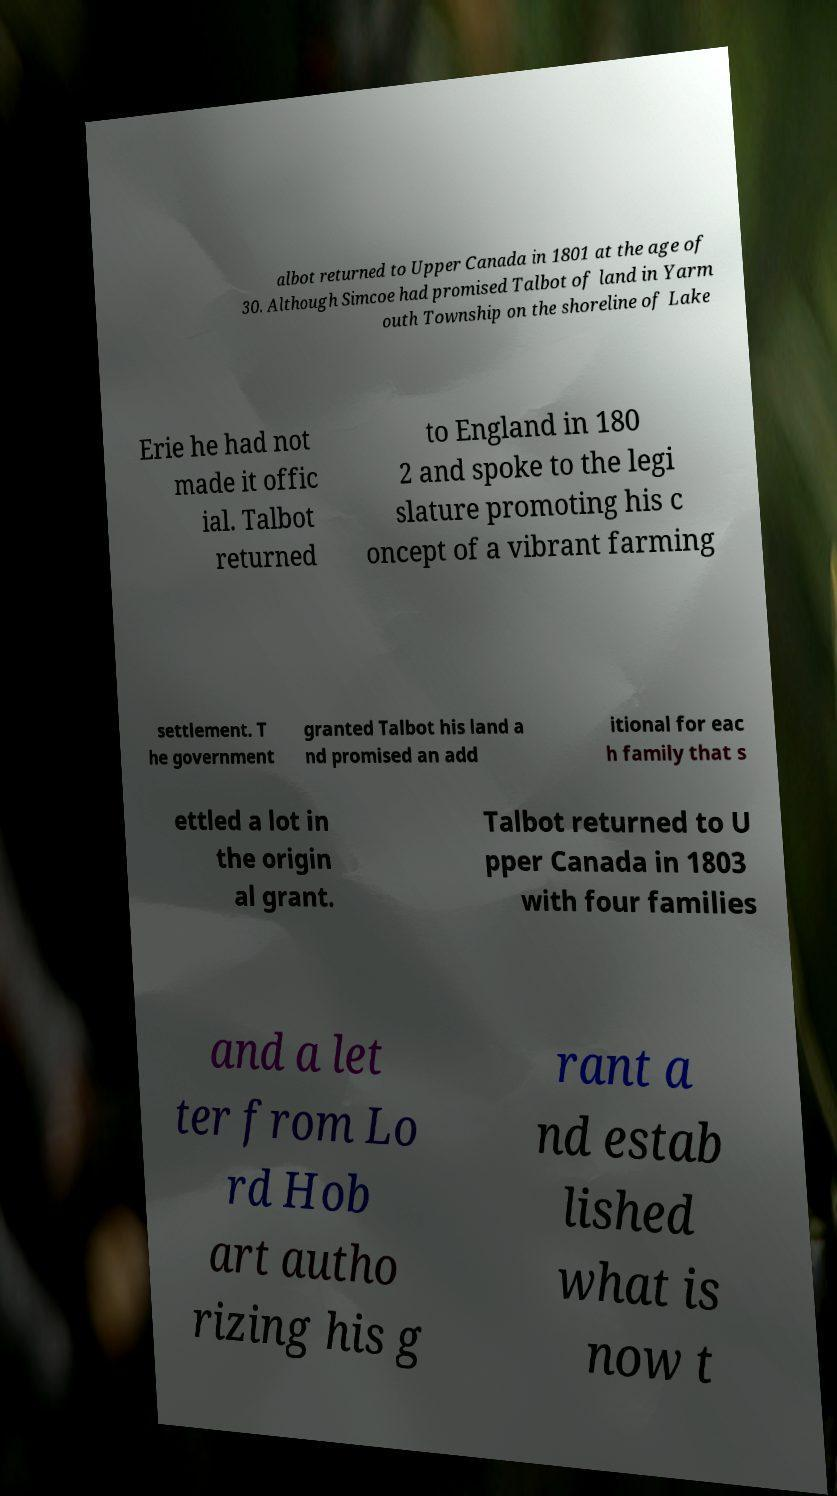Please read and relay the text visible in this image. What does it say? albot returned to Upper Canada in 1801 at the age of 30. Although Simcoe had promised Talbot of land in Yarm outh Township on the shoreline of Lake Erie he had not made it offic ial. Talbot returned to England in 180 2 and spoke to the legi slature promoting his c oncept of a vibrant farming settlement. T he government granted Talbot his land a nd promised an add itional for eac h family that s ettled a lot in the origin al grant. Talbot returned to U pper Canada in 1803 with four families and a let ter from Lo rd Hob art autho rizing his g rant a nd estab lished what is now t 